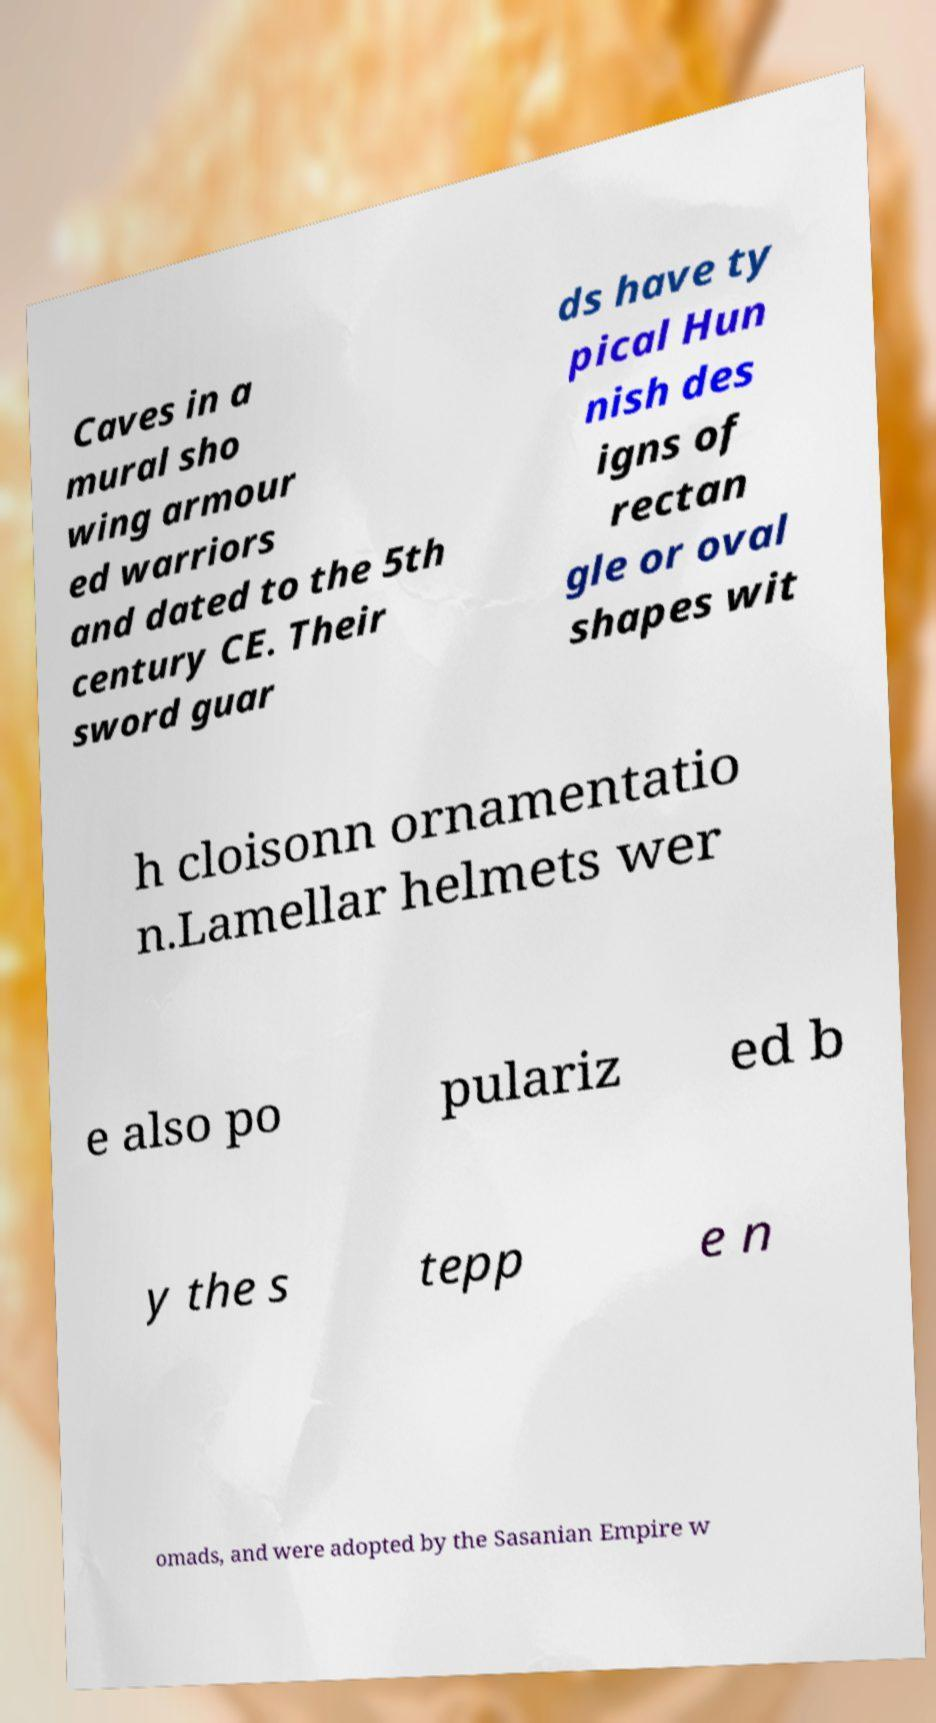Could you assist in decoding the text presented in this image and type it out clearly? Caves in a mural sho wing armour ed warriors and dated to the 5th century CE. Their sword guar ds have ty pical Hun nish des igns of rectan gle or oval shapes wit h cloisonn ornamentatio n.Lamellar helmets wer e also po pulariz ed b y the s tepp e n omads, and were adopted by the Sasanian Empire w 